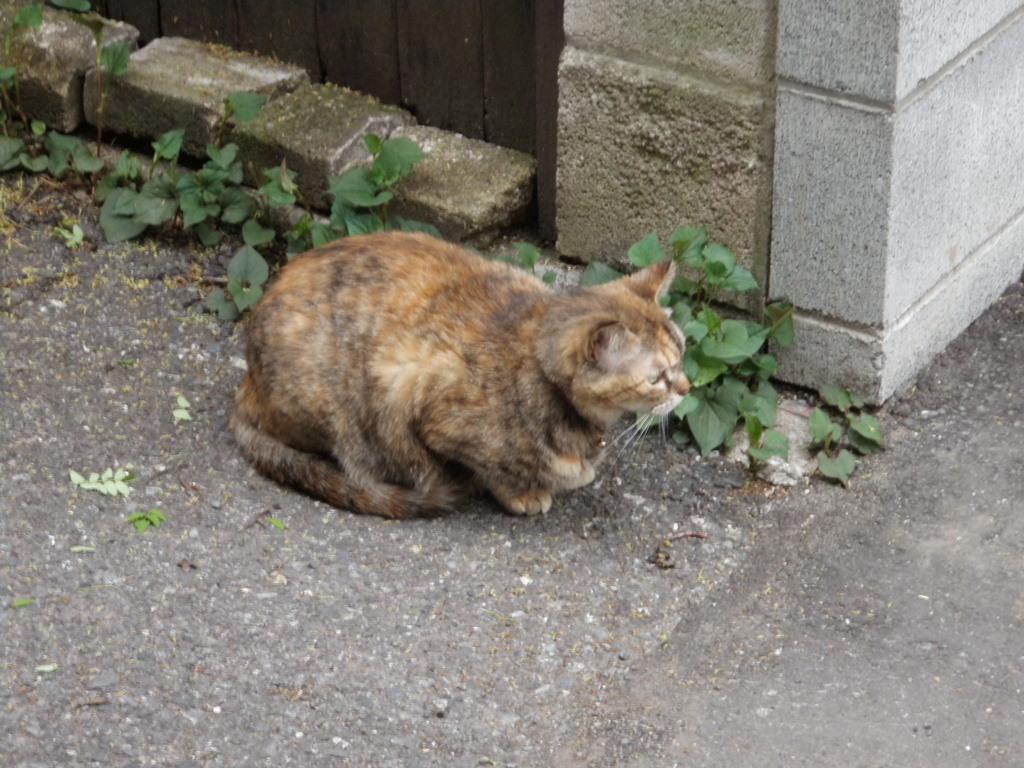Can you describe this image briefly? In this picture we can see a cat, few plants and bricks. 